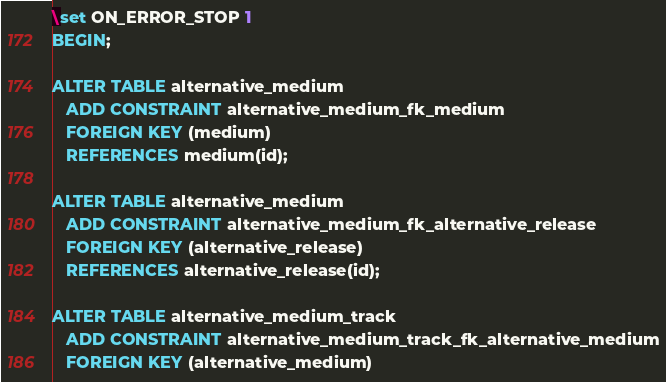Convert code to text. <code><loc_0><loc_0><loc_500><loc_500><_SQL_>\set ON_ERROR_STOP 1
BEGIN;

ALTER TABLE alternative_medium
   ADD CONSTRAINT alternative_medium_fk_medium
   FOREIGN KEY (medium)
   REFERENCES medium(id);

ALTER TABLE alternative_medium
   ADD CONSTRAINT alternative_medium_fk_alternative_release
   FOREIGN KEY (alternative_release)
   REFERENCES alternative_release(id);

ALTER TABLE alternative_medium_track
   ADD CONSTRAINT alternative_medium_track_fk_alternative_medium
   FOREIGN KEY (alternative_medium)</code> 